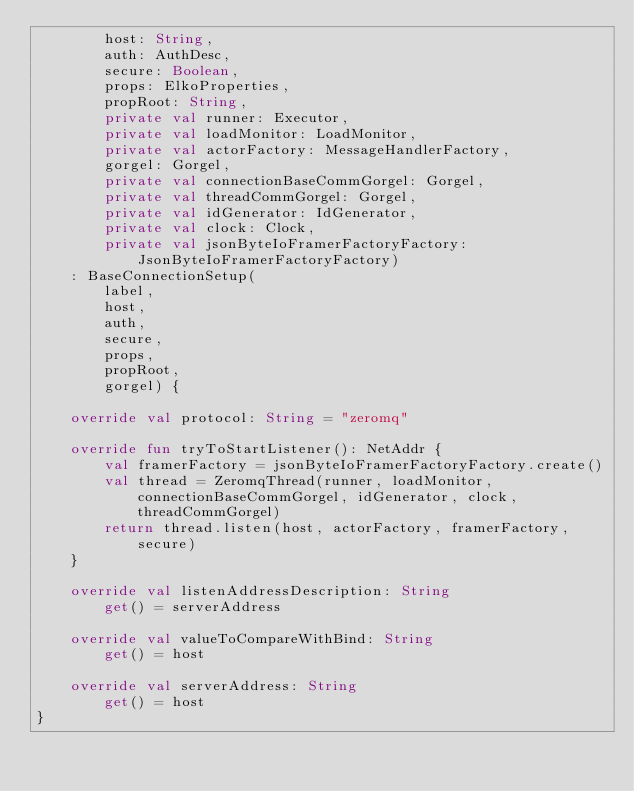<code> <loc_0><loc_0><loc_500><loc_500><_Kotlin_>        host: String,
        auth: AuthDesc,
        secure: Boolean,
        props: ElkoProperties,
        propRoot: String,
        private val runner: Executor,
        private val loadMonitor: LoadMonitor,
        private val actorFactory: MessageHandlerFactory,
        gorgel: Gorgel,
        private val connectionBaseCommGorgel: Gorgel,
        private val threadCommGorgel: Gorgel,
        private val idGenerator: IdGenerator,
        private val clock: Clock,
        private val jsonByteIoFramerFactoryFactory: JsonByteIoFramerFactoryFactory)
    : BaseConnectionSetup(
        label,
        host,
        auth,
        secure,
        props,
        propRoot,
        gorgel) {

    override val protocol: String = "zeromq"

    override fun tryToStartListener(): NetAddr {
        val framerFactory = jsonByteIoFramerFactoryFactory.create()
        val thread = ZeromqThread(runner, loadMonitor, connectionBaseCommGorgel, idGenerator, clock, threadCommGorgel)
        return thread.listen(host, actorFactory, framerFactory, secure)
    }

    override val listenAddressDescription: String
        get() = serverAddress

    override val valueToCompareWithBind: String
        get() = host

    override val serverAddress: String
        get() = host
}
</code> 